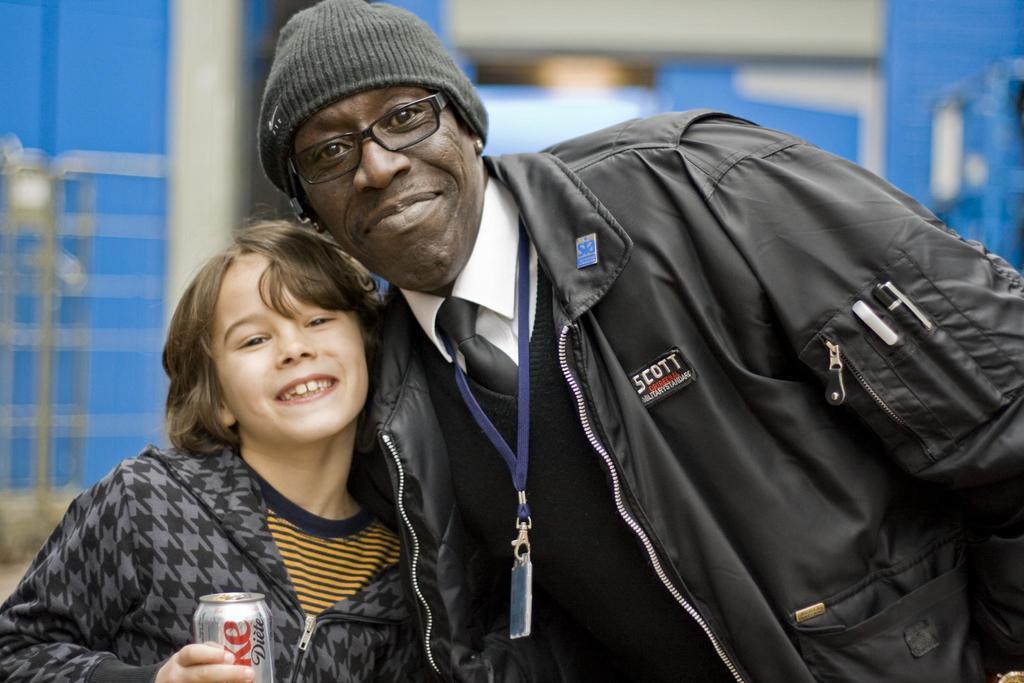Can you describe this image briefly? In this picture there is a African man wearing black jacket with ID card in the neck. Smiling and giving a pose into the camera. Beside there is a small girl wearing black hoodie and holding a coke can in the hand. Behind there is a blur background. 